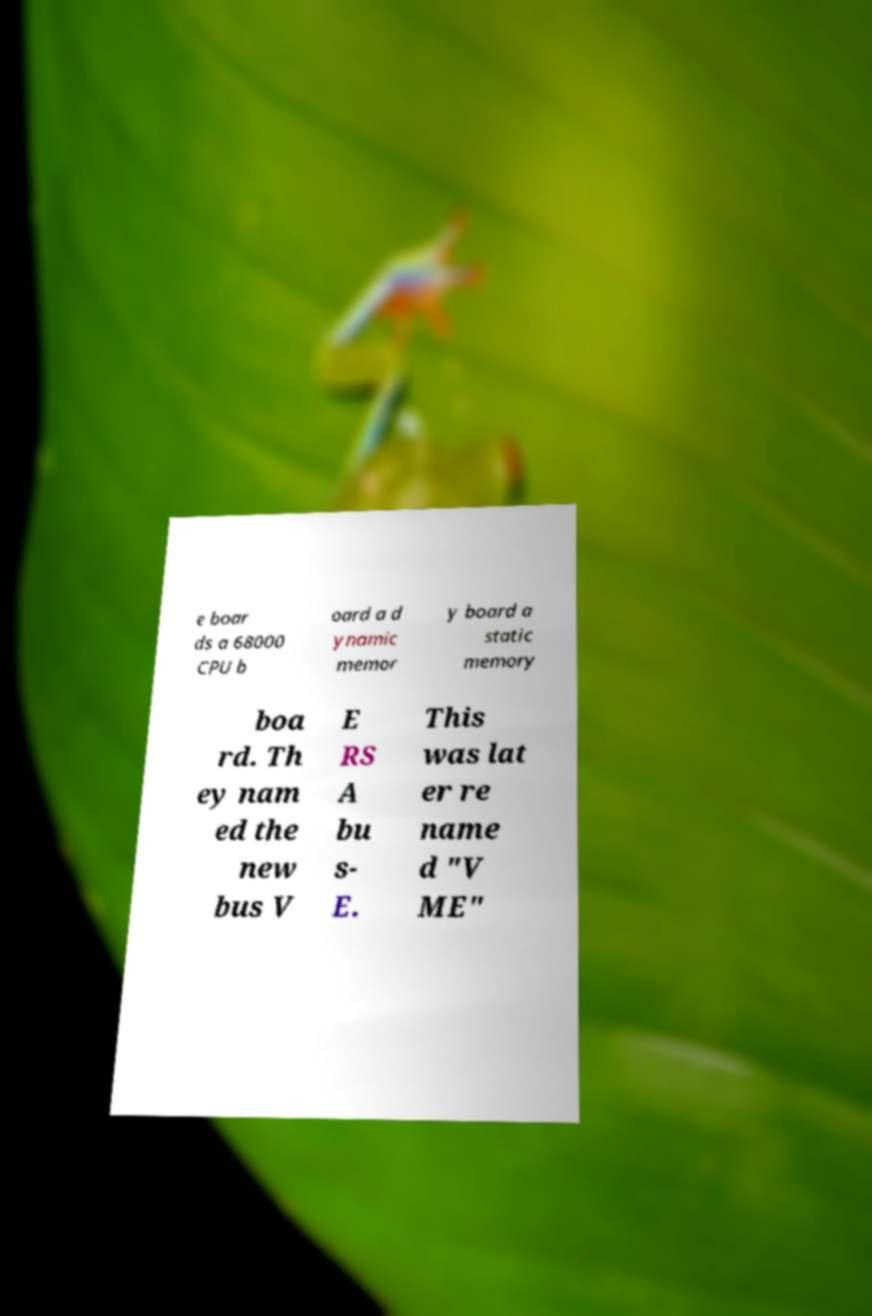Please read and relay the text visible in this image. What does it say? e boar ds a 68000 CPU b oard a d ynamic memor y board a static memory boa rd. Th ey nam ed the new bus V E RS A bu s- E. This was lat er re name d "V ME" 